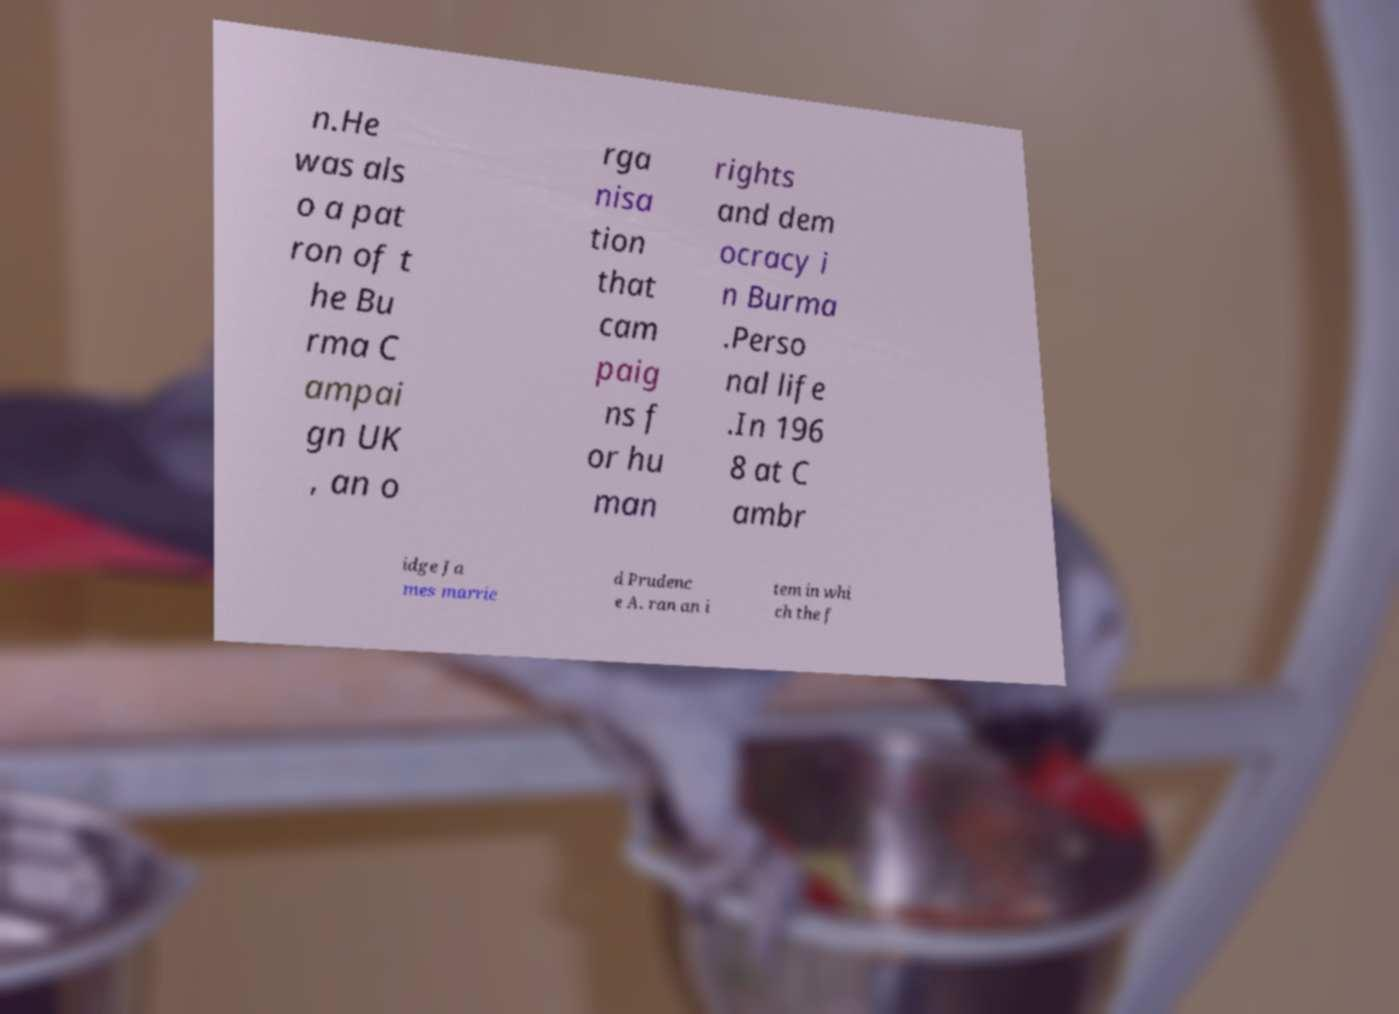Can you accurately transcribe the text from the provided image for me? n.He was als o a pat ron of t he Bu rma C ampai gn UK , an o rga nisa tion that cam paig ns f or hu man rights and dem ocracy i n Burma .Perso nal life .In 196 8 at C ambr idge Ja mes marrie d Prudenc e A. ran an i tem in whi ch the f 